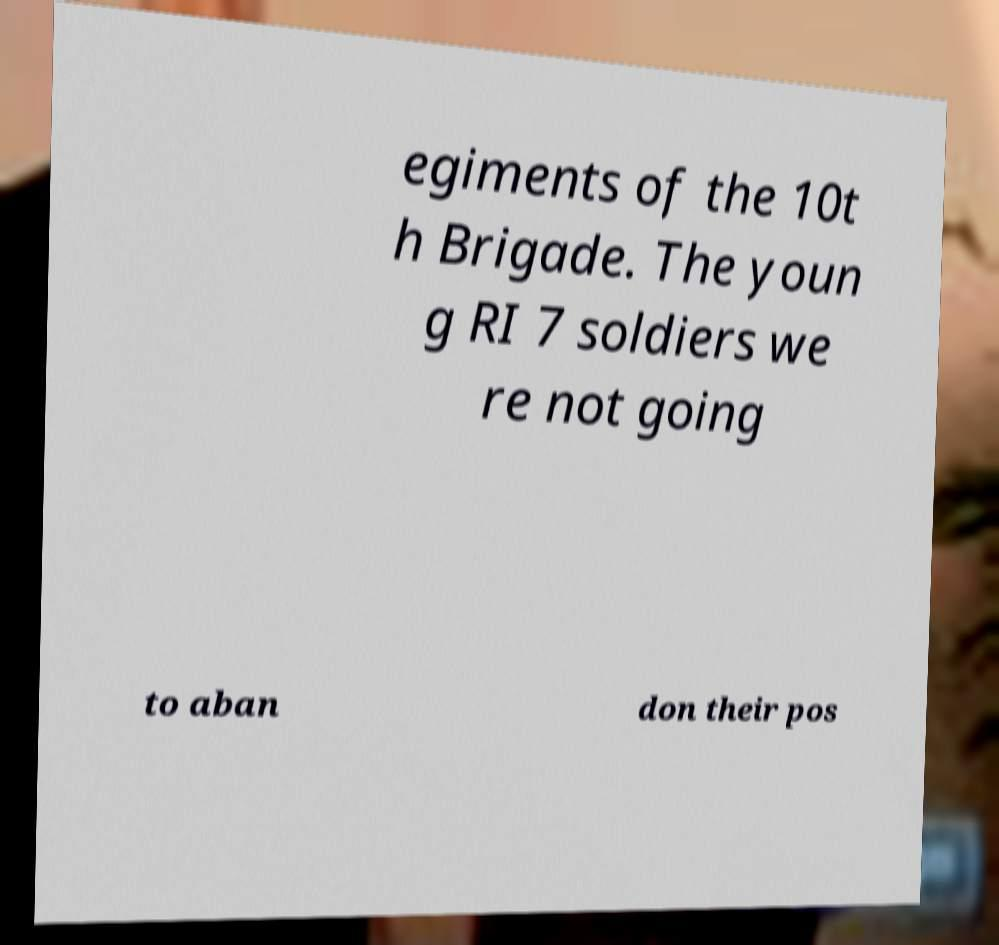Can you accurately transcribe the text from the provided image for me? egiments of the 10t h Brigade. The youn g RI 7 soldiers we re not going to aban don their pos 